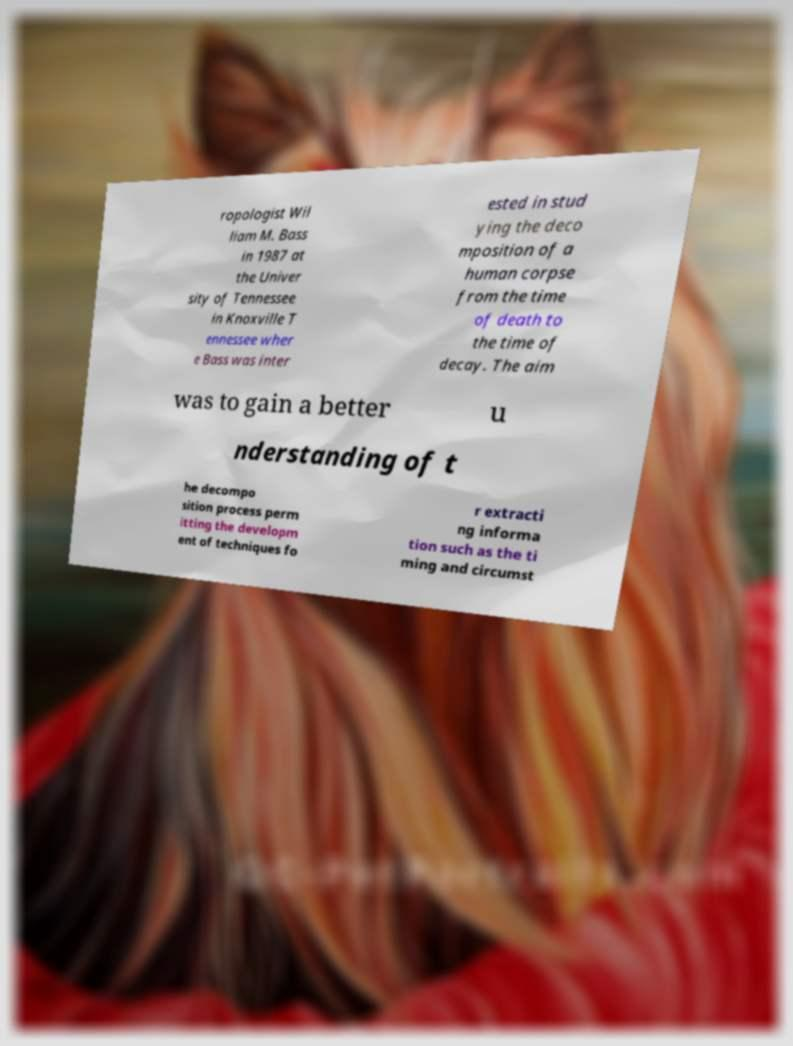Can you accurately transcribe the text from the provided image for me? ropologist Wil liam M. Bass in 1987 at the Univer sity of Tennessee in Knoxville T ennessee wher e Bass was inter ested in stud ying the deco mposition of a human corpse from the time of death to the time of decay. The aim was to gain a better u nderstanding of t he decompo sition process perm itting the developm ent of techniques fo r extracti ng informa tion such as the ti ming and circumst 